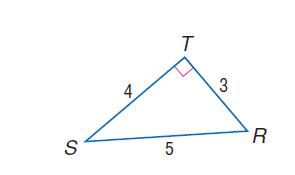Answer the mathemtical geometry problem and directly provide the correct option letter.
Question: find \cos S.
Choices: A: 0.2 B: 0.4 C: 0.6 D: 0.8 D 